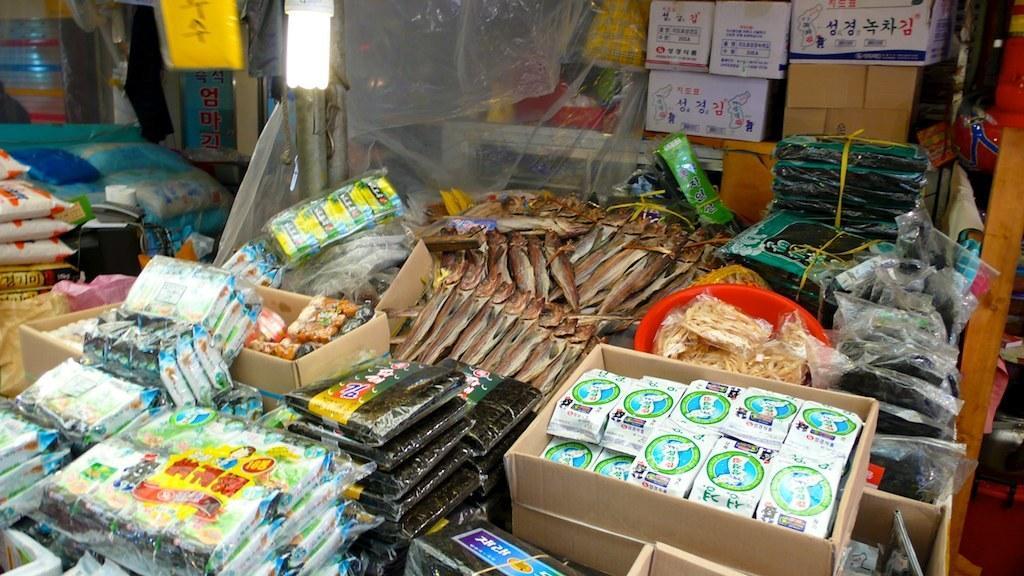How would you summarize this image in a sentence or two? In this picture we can see boxes, packets, fishes, food items, basket, light bulb and some objects. 